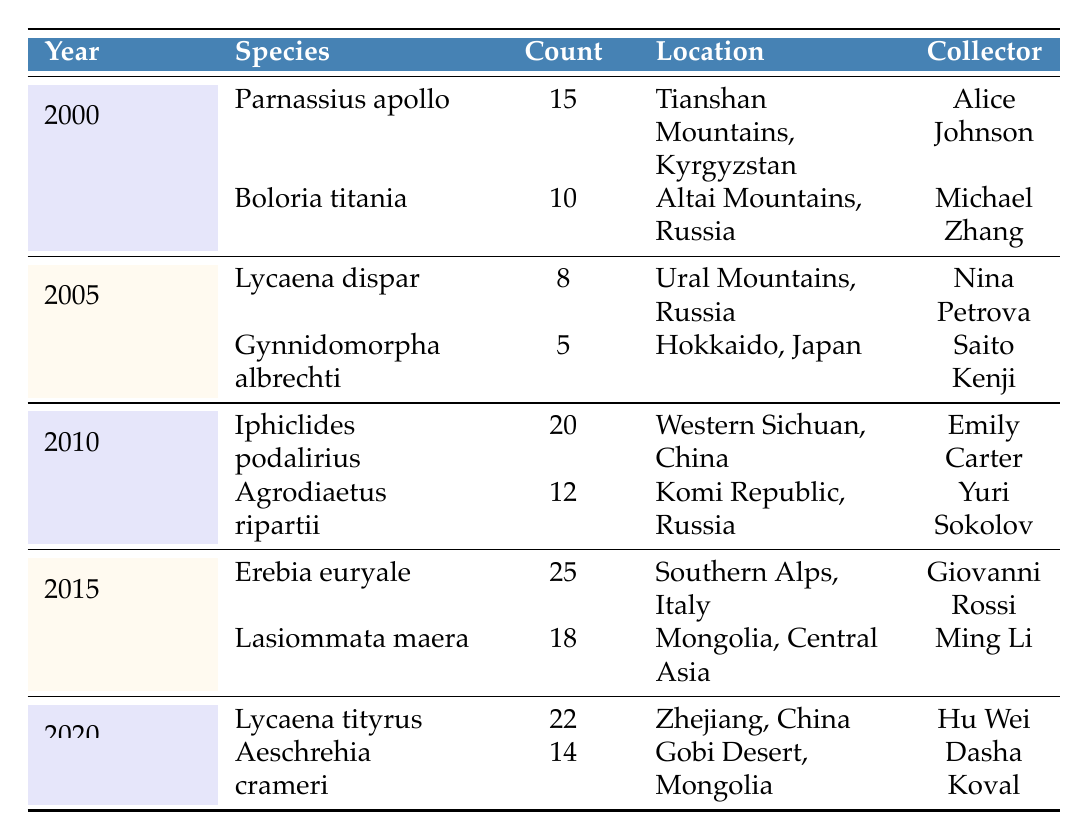What is the most collected butterfly species in 2015? In 2015, Erebia euryale was collected 25 times, which is the highest count for that year. Lasiommata maera follows with a count of 18.
Answer: Erebia euryale Which collector found the species Iphiclides podalirius? Looking at the 2010 row, Iphiclides podalirius was collected by Emily Carter.
Answer: Emily Carter How many species were collected in total by all collectors from 2000 to 2020? We add the counts of all species from each year: 15 (2000) + 10 (2000) + 8 (2005) + 5 (2005) + 20 (2010) + 12 (2010) + 25 (2015) + 18 (2015) + 22 (2020) + 14 (2020) =  15 + 10 + 8 + 5 + 20 + 12 + 25 + 18 + 22 + 14 =  159.
Answer: 159 Did Michael Zhang collect more butterflies than Hu Wei? Michael Zhang collected Boloria titania 10 times in 2000, while Hu Wei collected Lycaena tityrus 22 times in 2020. Since 22 is greater than 10, the answer is yes.
Answer: Yes What is the average number of butterflies collected per year from 2000 to 2020? First, we calculate the total number of butterflies collected: 159 (as calculated earlier). There are 5 years with data (2000, 2005, 2010, 2015, and 2020), so we divide 159 by 5, giving us an average of 31.8.
Answer: 31.8 In which year were the fewest butterflies collected, and how many were collected? The year with the fewest butterflies collected is 2005, with a total of 13 butterflies (8 from Lycaena dispar and 5 from Gynnidomorpha albrechti).
Answer: 2005, 13 What species was collected by the least number of individuals in 2020? In 2020, Aeschrehia crameri was collected 14 times, which is fewer than the 22 times by Lycaena tityrus. So, Aeschrehia crameri has the least count for the year.
Answer: Aeschrehia crameri Who collected more butterflies, Giovanni Rossi or Yuri Sokolov? Giovanni Rossi collected 25 butterflies (Erebia euryale) in 2015, while Yuri Sokolov collected 12 butterflies (Agrodiaetus ripartii) in 2010. Since 25 is greater than 12, Giovanni Rossi collected more.
Answer: Giovanni Rossi 